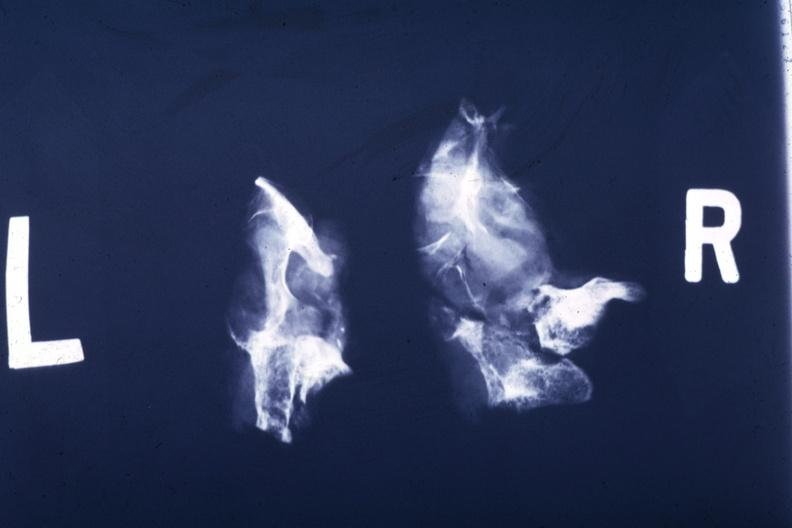s carcinoma metastatic lung present?
Answer the question using a single word or phrase. No 